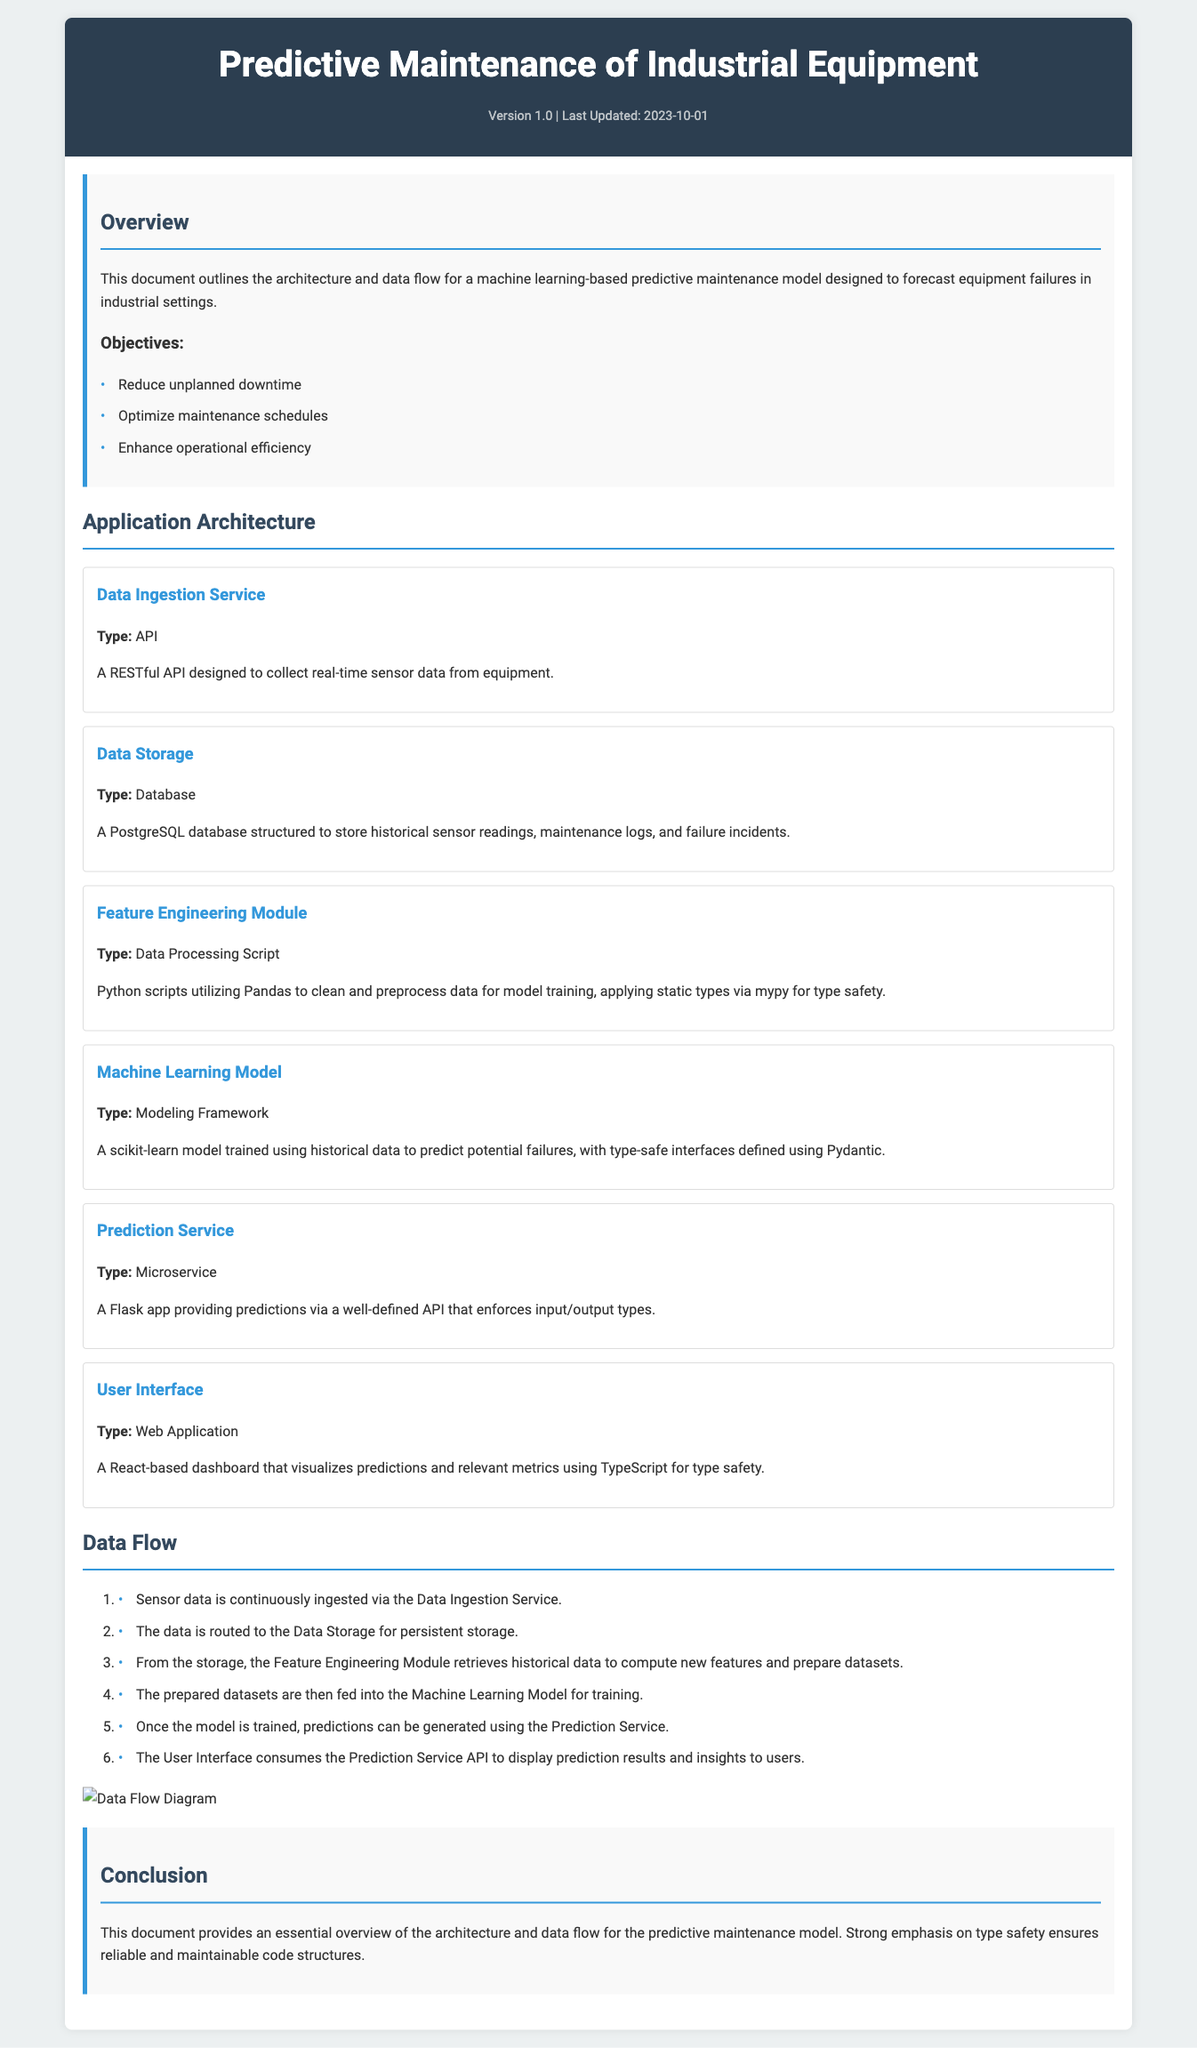What is the version of the document? The version of the document is indicated in the meta section, where it states "Version 1.0".
Answer: Version 1.0 When was the document last updated? The last updated date is mentioned in the meta section as "2023-10-01".
Answer: 2023-10-01 What type of database is used for data storage? The type of database used for data storage is specified in the "Data Storage" component, which states it is a PostgreSQL database.
Answer: PostgreSQL What is the main objective of the project? The objectives include reducing unplanned downtime, optimizing maintenance schedules, and enhancing operational efficiency, with the primary focus being on reducing unplanned downtime.
Answer: Reduce unplanned downtime Which module utilizes Python scripts? The module that utilizes Python scripts is the "Feature Engineering Module" which is involved in data processing.
Answer: Feature Engineering Module What type of application is the User Interface based on? The type of application for the User Interface is a web application stated in its component description.
Answer: Web Application How many steps are in the data flow? The total number of steps outlined in the data flow section is six, detailing the sequence from data ingestion to user interface consumption.
Answer: Six What framework is used for the Machine Learning Model? The framework used for the Machine Learning Model is specified in the description as scikit-learn.
Answer: scikit-learn What is emphasized in the conclusion of the document? The conclusion emphasizes the importance of type safety in ensuring reliable and maintainable code structures as discussed throughout the document.
Answer: Type safety 